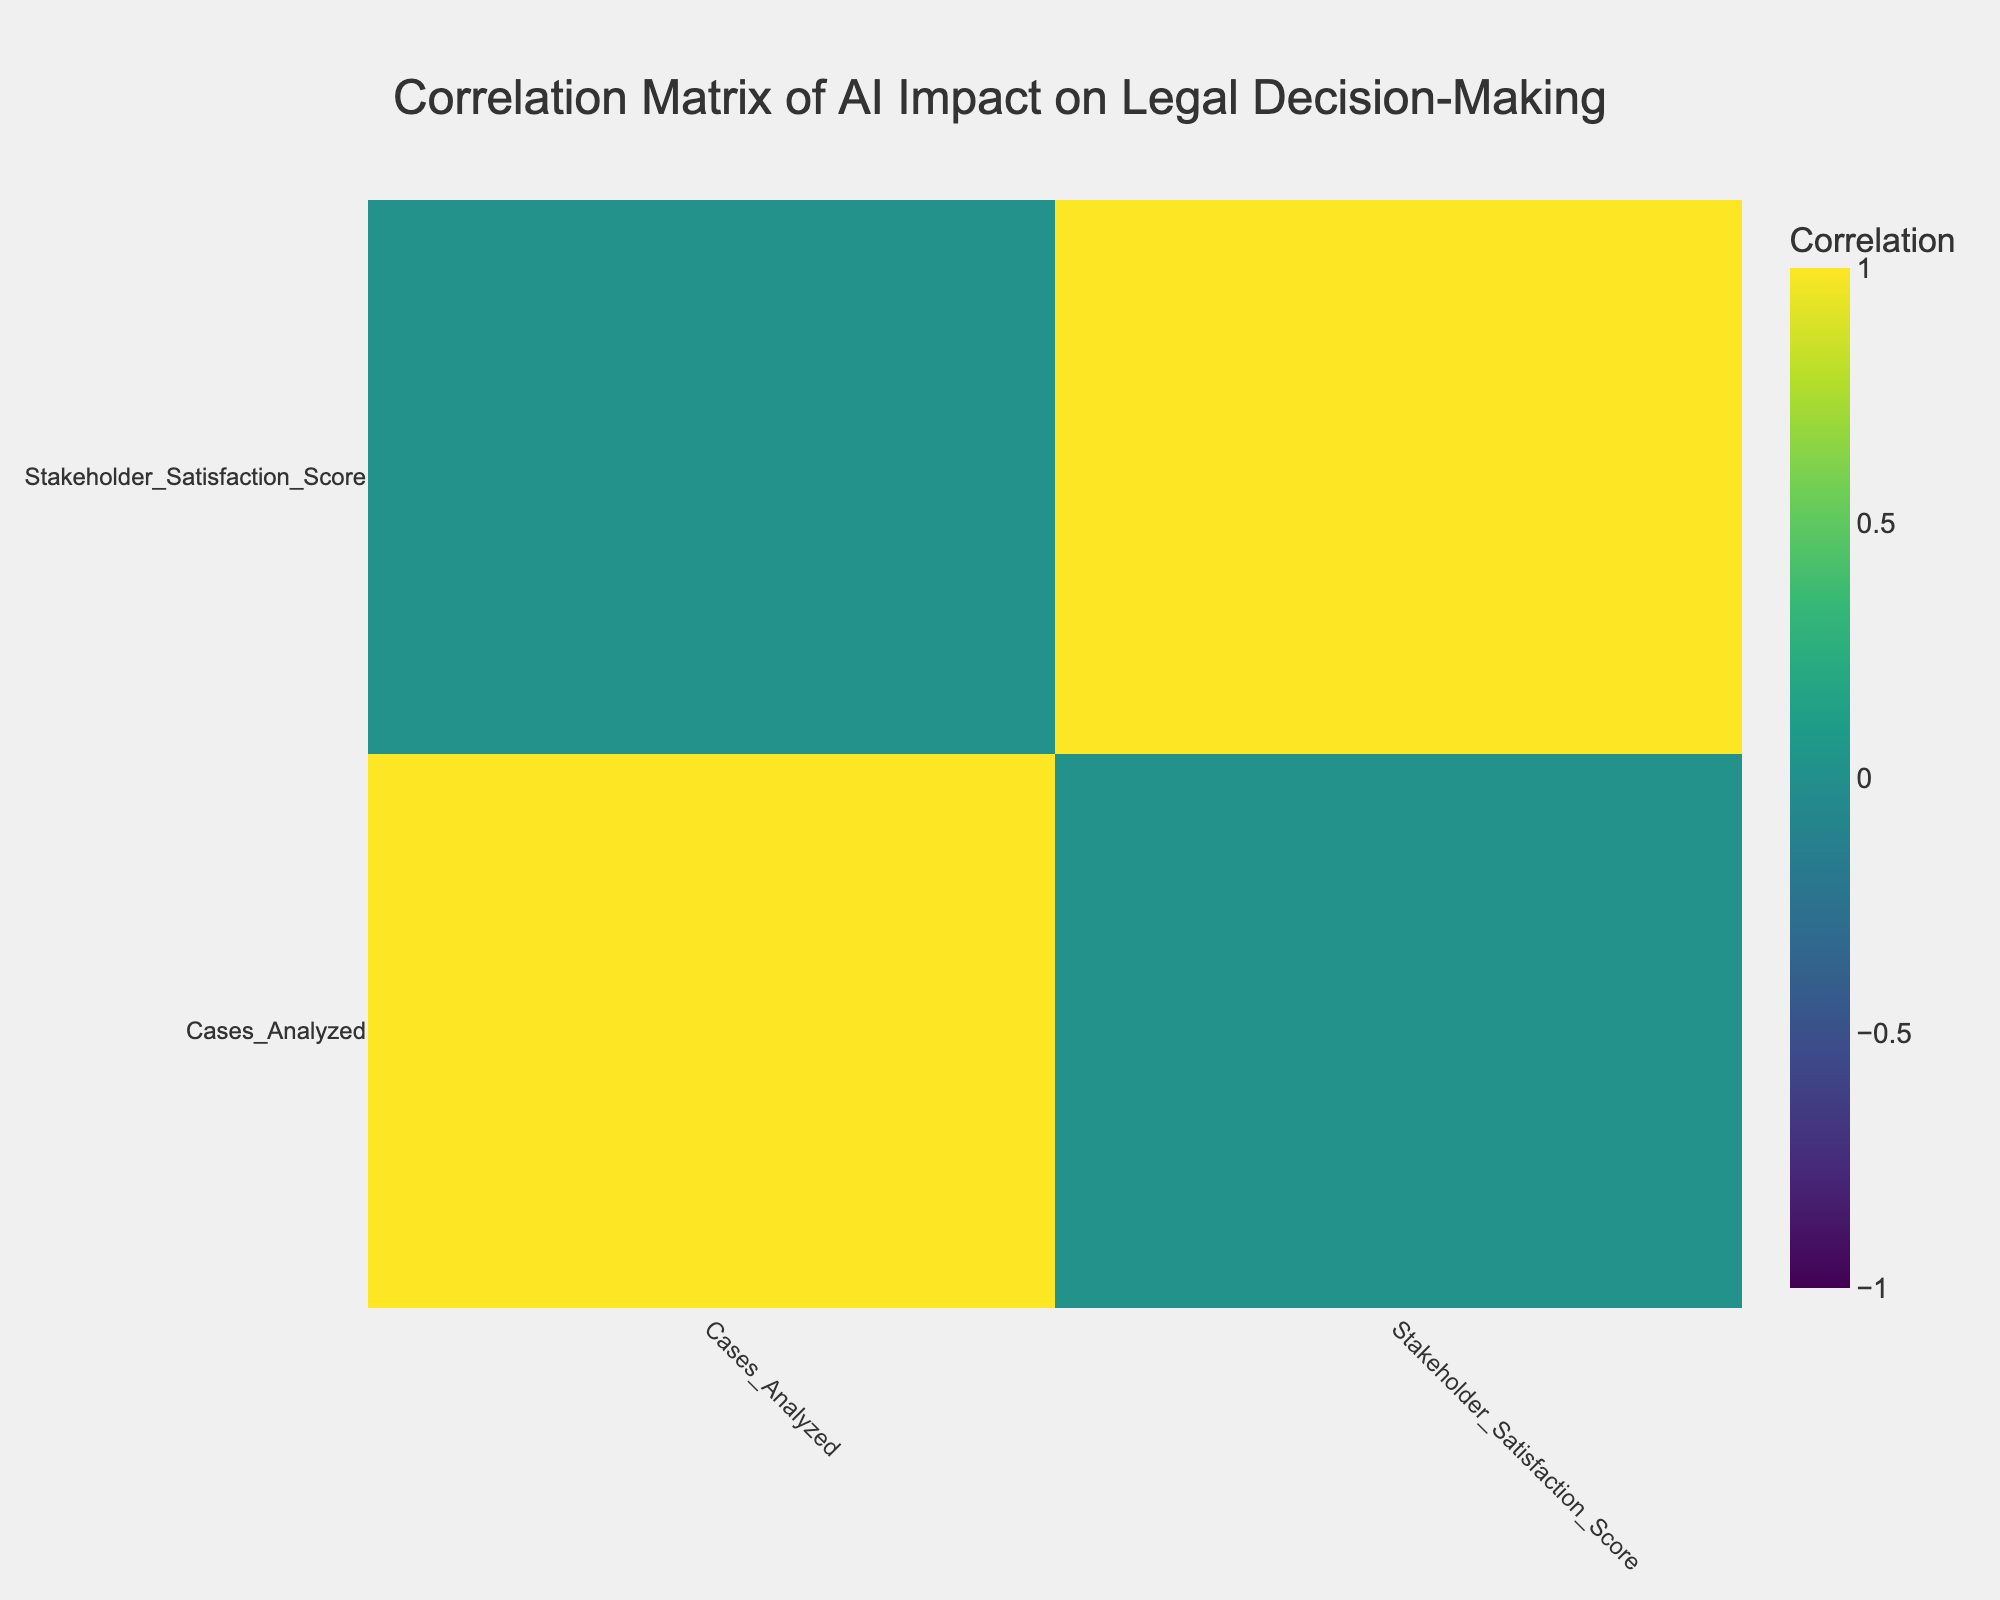What is the improvement in outcome rate for Machine Learning Algorithms? The improvement in outcome rate for Machine Learning Algorithms is listed in the table. Looking at the row for Machine Learning Algorithms, the specific value is 25%.
Answer: 25% Which AI technology has the highest stakeholder satisfaction score? The stakeholder satisfaction score is given for each AI technology. By comparing the scores, we find that Evidence Classification Tools has the highest score of 92.
Answer: Evidence Classification Tools Is the impact on decision-making from Robotic Process Automation positive? The impact on decision-making for Robotic Process Automation is noted in the table. It is categorized as "Low," which does not indicate a positive impact.
Answer: No What is the average improvement in outcome rate for all AI technologies listed? To find the average, we first sum the improvement rates: 15% + 10% + 25% + 12% + 22% + 8% + 20% + 18% + 11% + 5% =  121%. Then we divide this sum by the number of AI technologies, which is 10. Therefore, the average is 121% / 10 = 12.1%.
Answer: 12.1% Which AI technology contributes a moderate impact on decision-making? The table lists the impacts for all technologies. From a review of the data, we see that Natural Language Processing, Legal Chatbots, and AI-Powered Legal Research are categorized as having a moderate impact on decision-making.
Answer: Natural Language Processing, Legal Chatbots, AI-Powered Legal Research If we consider only technologies with a high improvement in outcome rate, what are they? For this question, we need to identify AI technologies with an improvement in outcome rate higher than 20%. By examining the table, we find that Machine Learning Algorithms (25%) and Document Review Automation (22%) meet this criterion.
Answer: Machine Learning Algorithms, Document Review Automation What is the correlation between stakeholder satisfaction score and improvement in outcome rate? The correlation is determined by examining the values for both metrics across the different technologies. By calculating the correlation visually or numerically, one would assess changes in one variable relative to changes in another and interpret the resulting correlation coefficient. From the data, we can identify a positive correlation.
Answer: Positive correlation Is the average stakeholder satisfaction score across all technologies above 80? First, we calculate the average satisfaction score by summing all scores (85 + 80 + 90 + 75 + 88 + 70 + 92 + 85 + 82 + 65 =  825) and dividing it by the number of technologies (10). The average is 825 / 10 = 82.5, which is above 80.
Answer: Yes What are the AI technologies with positive impacts on decision-making? The table classifies impacts on decision-making for each AI technology. By filtering out those categorized as "Positive," we see that Predictive Analytics, Legal Chatbots, and Case Outcome Prediction fall into this category.
Answer: Predictive Analytics, Legal Chatbots, Case Outcome Prediction 